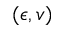<formula> <loc_0><loc_0><loc_500><loc_500>( \epsilon , v )</formula> 